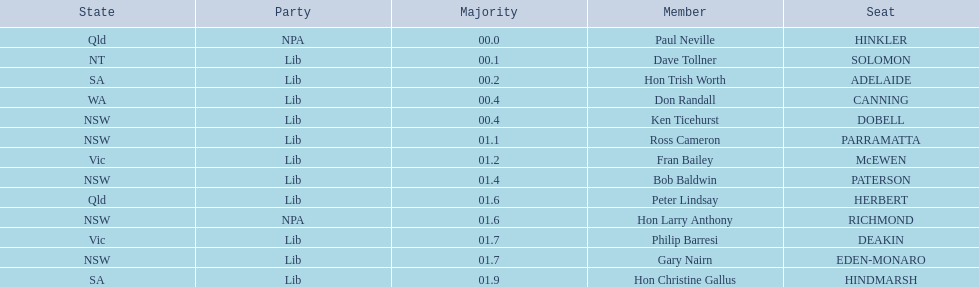What is the difference in majority between hindmarsh and hinkler? 01.9. 